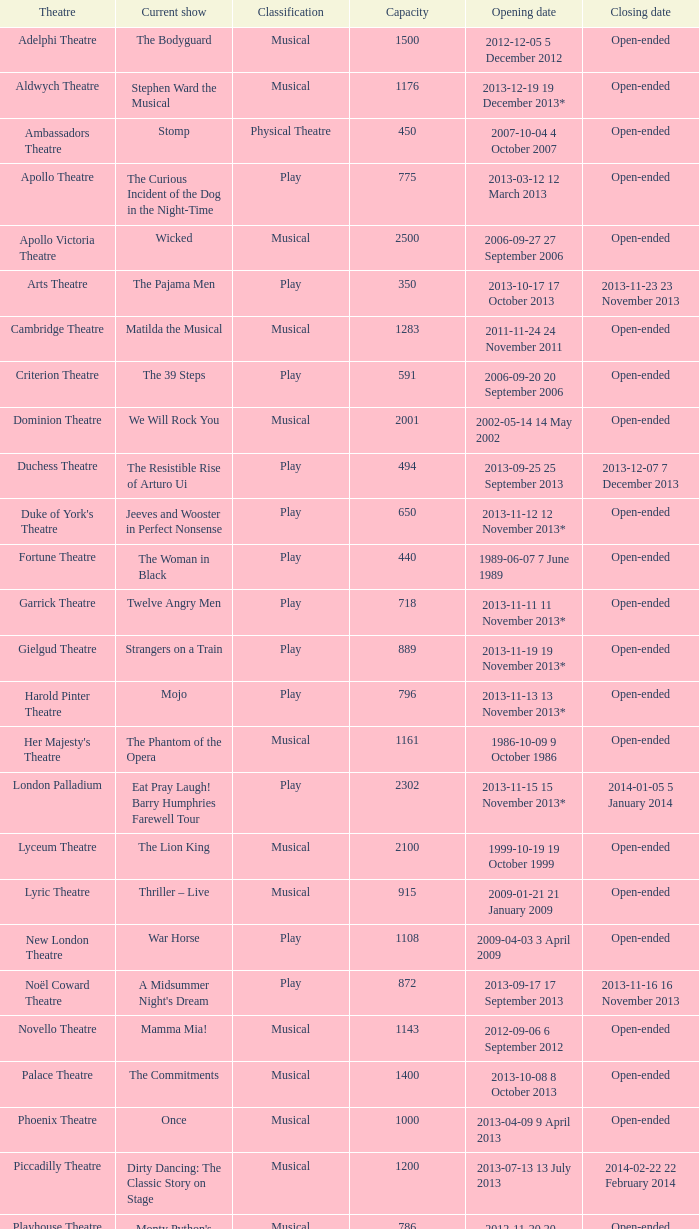What launch date can hold up to 100 individuals? 2013-11-01 1 November 2013. 